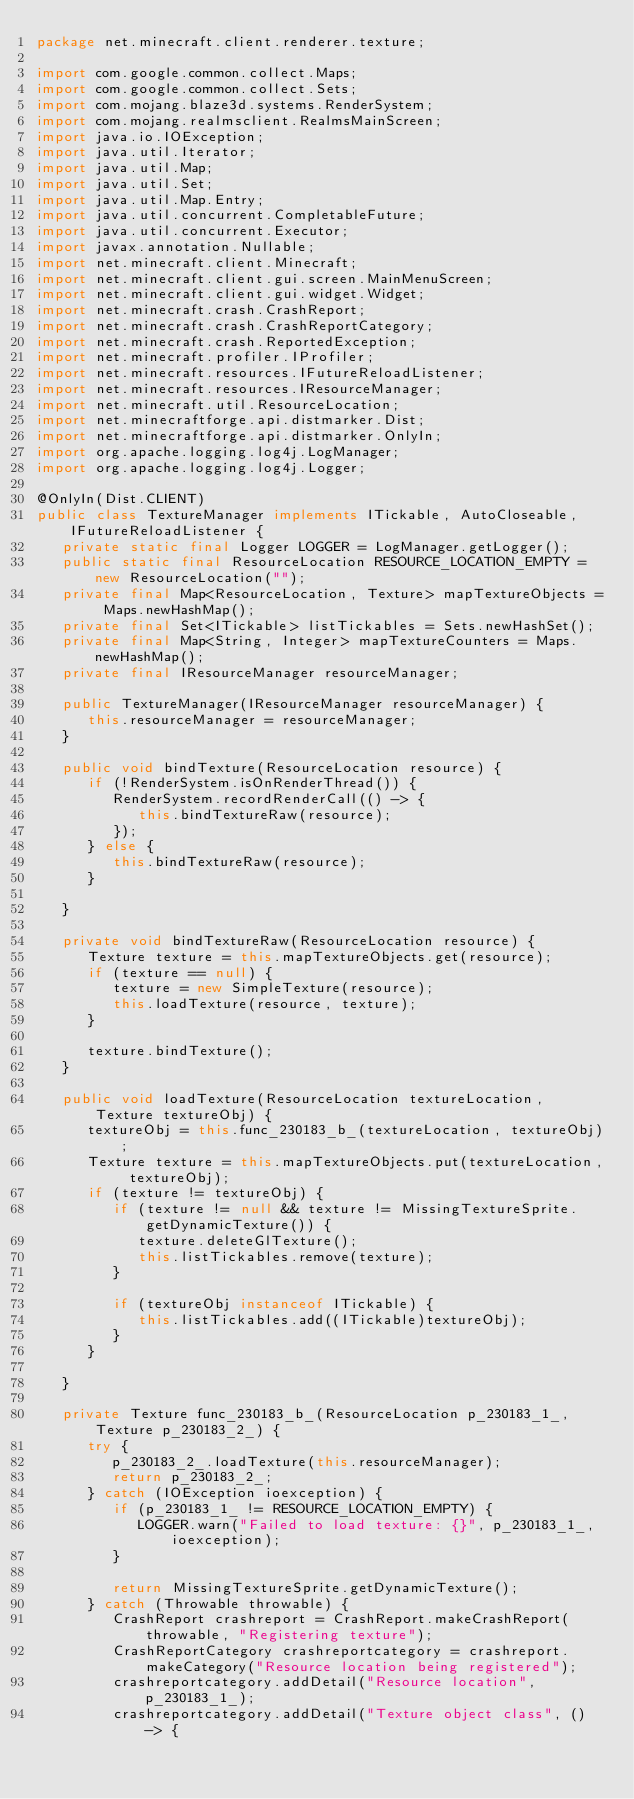Convert code to text. <code><loc_0><loc_0><loc_500><loc_500><_Java_>package net.minecraft.client.renderer.texture;

import com.google.common.collect.Maps;
import com.google.common.collect.Sets;
import com.mojang.blaze3d.systems.RenderSystem;
import com.mojang.realmsclient.RealmsMainScreen;
import java.io.IOException;
import java.util.Iterator;
import java.util.Map;
import java.util.Set;
import java.util.Map.Entry;
import java.util.concurrent.CompletableFuture;
import java.util.concurrent.Executor;
import javax.annotation.Nullable;
import net.minecraft.client.Minecraft;
import net.minecraft.client.gui.screen.MainMenuScreen;
import net.minecraft.client.gui.widget.Widget;
import net.minecraft.crash.CrashReport;
import net.minecraft.crash.CrashReportCategory;
import net.minecraft.crash.ReportedException;
import net.minecraft.profiler.IProfiler;
import net.minecraft.resources.IFutureReloadListener;
import net.minecraft.resources.IResourceManager;
import net.minecraft.util.ResourceLocation;
import net.minecraftforge.api.distmarker.Dist;
import net.minecraftforge.api.distmarker.OnlyIn;
import org.apache.logging.log4j.LogManager;
import org.apache.logging.log4j.Logger;

@OnlyIn(Dist.CLIENT)
public class TextureManager implements ITickable, AutoCloseable, IFutureReloadListener {
   private static final Logger LOGGER = LogManager.getLogger();
   public static final ResourceLocation RESOURCE_LOCATION_EMPTY = new ResourceLocation("");
   private final Map<ResourceLocation, Texture> mapTextureObjects = Maps.newHashMap();
   private final Set<ITickable> listTickables = Sets.newHashSet();
   private final Map<String, Integer> mapTextureCounters = Maps.newHashMap();
   private final IResourceManager resourceManager;

   public TextureManager(IResourceManager resourceManager) {
      this.resourceManager = resourceManager;
   }

   public void bindTexture(ResourceLocation resource) {
      if (!RenderSystem.isOnRenderThread()) {
         RenderSystem.recordRenderCall(() -> {
            this.bindTextureRaw(resource);
         });
      } else {
         this.bindTextureRaw(resource);
      }

   }

   private void bindTextureRaw(ResourceLocation resource) {
      Texture texture = this.mapTextureObjects.get(resource);
      if (texture == null) {
         texture = new SimpleTexture(resource);
         this.loadTexture(resource, texture);
      }

      texture.bindTexture();
   }

   public void loadTexture(ResourceLocation textureLocation, Texture textureObj) {
      textureObj = this.func_230183_b_(textureLocation, textureObj);
      Texture texture = this.mapTextureObjects.put(textureLocation, textureObj);
      if (texture != textureObj) {
         if (texture != null && texture != MissingTextureSprite.getDynamicTexture()) {
            texture.deleteGlTexture();
            this.listTickables.remove(texture);
         }

         if (textureObj instanceof ITickable) {
            this.listTickables.add((ITickable)textureObj);
         }
      }

   }

   private Texture func_230183_b_(ResourceLocation p_230183_1_, Texture p_230183_2_) {
      try {
         p_230183_2_.loadTexture(this.resourceManager);
         return p_230183_2_;
      } catch (IOException ioexception) {
         if (p_230183_1_ != RESOURCE_LOCATION_EMPTY) {
            LOGGER.warn("Failed to load texture: {}", p_230183_1_, ioexception);
         }

         return MissingTextureSprite.getDynamicTexture();
      } catch (Throwable throwable) {
         CrashReport crashreport = CrashReport.makeCrashReport(throwable, "Registering texture");
         CrashReportCategory crashreportcategory = crashreport.makeCategory("Resource location being registered");
         crashreportcategory.addDetail("Resource location", p_230183_1_);
         crashreportcategory.addDetail("Texture object class", () -> {</code> 